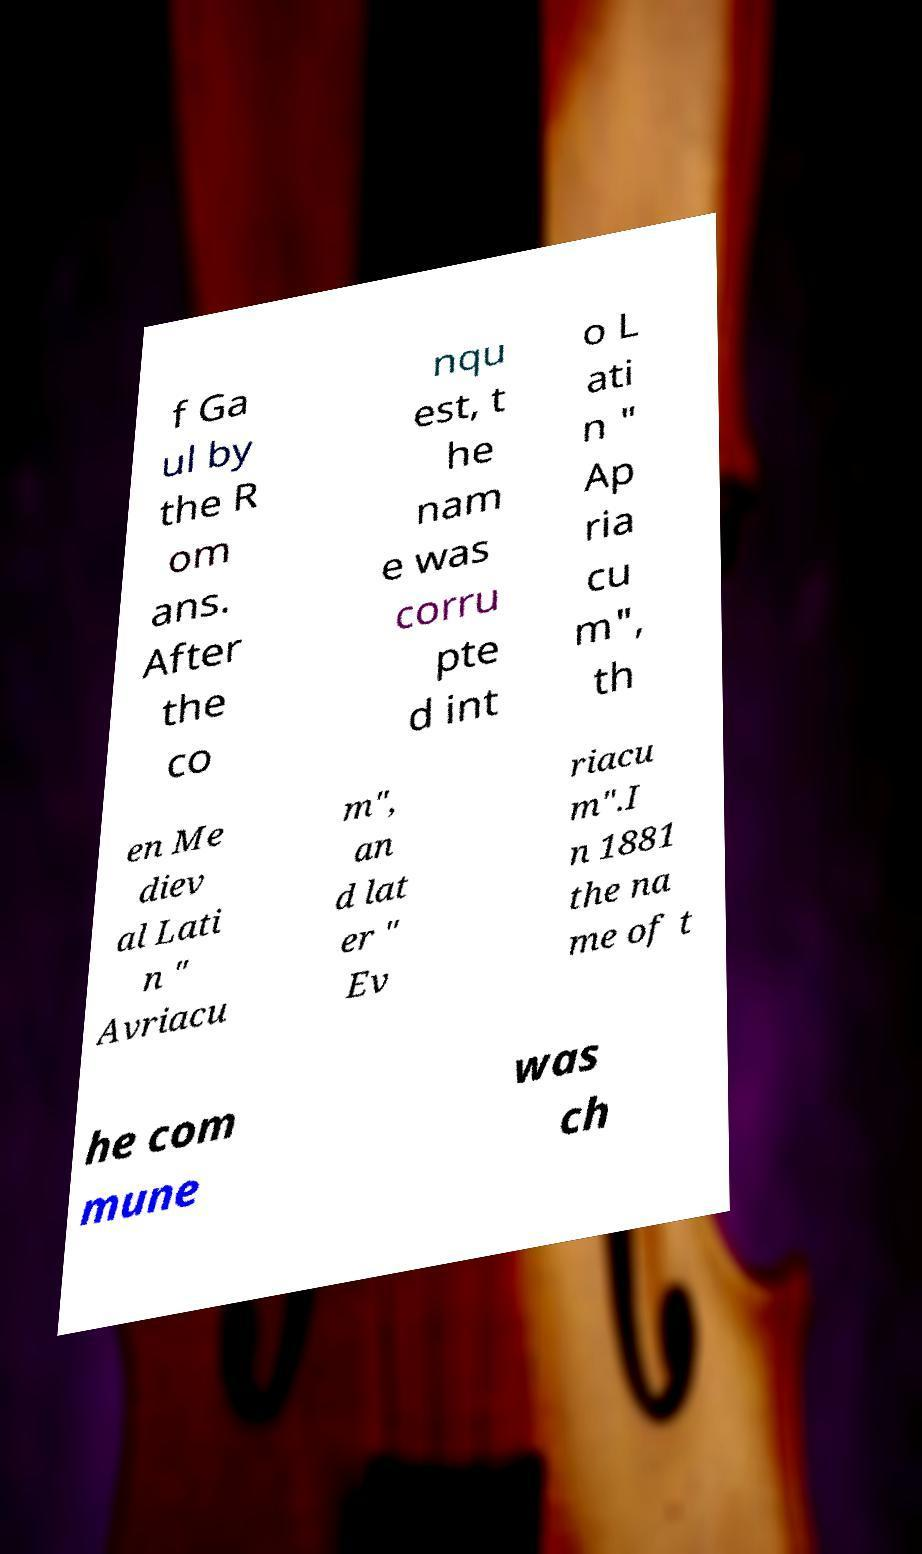Can you read and provide the text displayed in the image?This photo seems to have some interesting text. Can you extract and type it out for me? f Ga ul by the R om ans. After the co nqu est, t he nam e was corru pte d int o L ati n " Ap ria cu m", th en Me diev al Lati n " Avriacu m", an d lat er " Ev riacu m".I n 1881 the na me of t he com mune was ch 